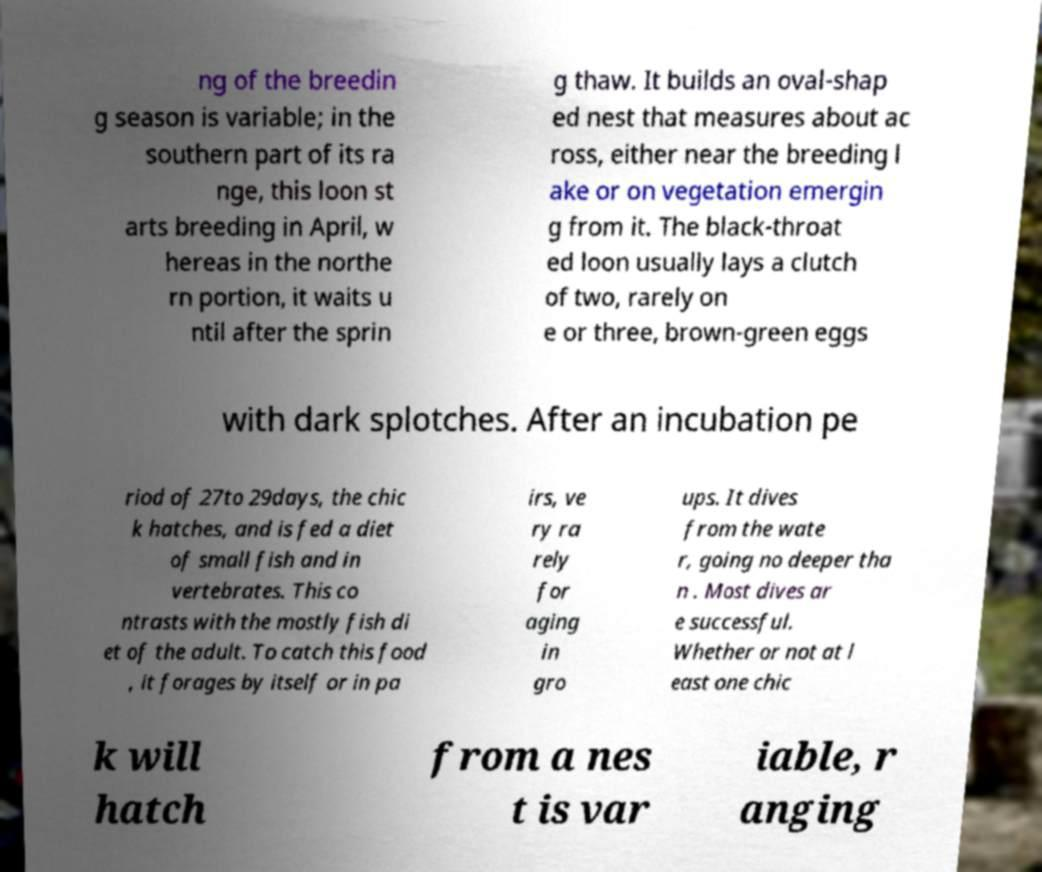Please identify and transcribe the text found in this image. ng of the breedin g season is variable; in the southern part of its ra nge, this loon st arts breeding in April, w hereas in the northe rn portion, it waits u ntil after the sprin g thaw. It builds an oval-shap ed nest that measures about ac ross, either near the breeding l ake or on vegetation emergin g from it. The black-throat ed loon usually lays a clutch of two, rarely on e or three, brown-green eggs with dark splotches. After an incubation pe riod of 27to 29days, the chic k hatches, and is fed a diet of small fish and in vertebrates. This co ntrasts with the mostly fish di et of the adult. To catch this food , it forages by itself or in pa irs, ve ry ra rely for aging in gro ups. It dives from the wate r, going no deeper tha n . Most dives ar e successful. Whether or not at l east one chic k will hatch from a nes t is var iable, r anging 